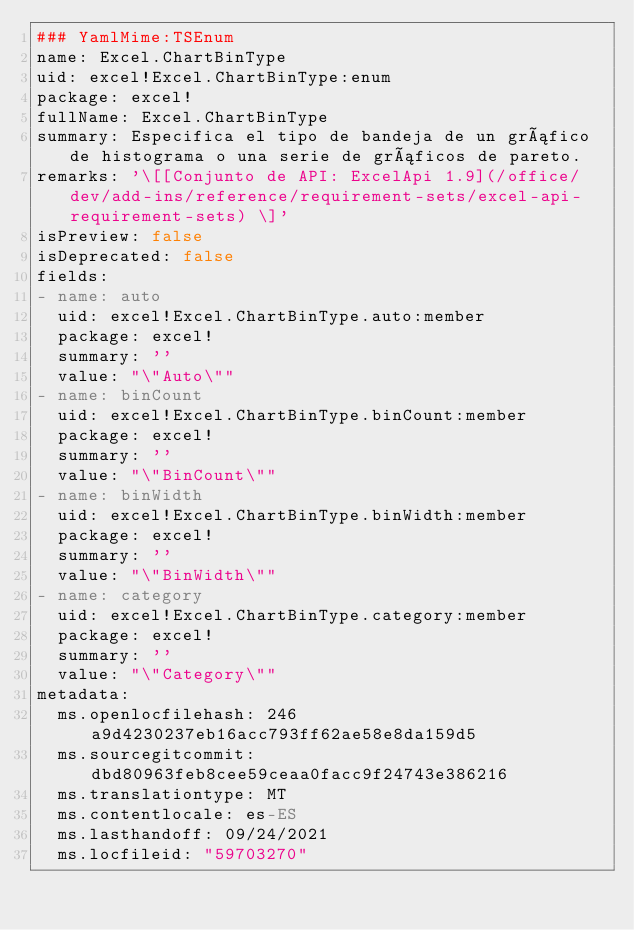Convert code to text. <code><loc_0><loc_0><loc_500><loc_500><_YAML_>### YamlMime:TSEnum
name: Excel.ChartBinType
uid: excel!Excel.ChartBinType:enum
package: excel!
fullName: Excel.ChartBinType
summary: Especifica el tipo de bandeja de un gráfico de histograma o una serie de gráficos de pareto.
remarks: '\[[Conjunto de API: ExcelApi 1.9](/office/dev/add-ins/reference/requirement-sets/excel-api-requirement-sets) \]'
isPreview: false
isDeprecated: false
fields:
- name: auto
  uid: excel!Excel.ChartBinType.auto:member
  package: excel!
  summary: ''
  value: "\"Auto\""
- name: binCount
  uid: excel!Excel.ChartBinType.binCount:member
  package: excel!
  summary: ''
  value: "\"BinCount\""
- name: binWidth
  uid: excel!Excel.ChartBinType.binWidth:member
  package: excel!
  summary: ''
  value: "\"BinWidth\""
- name: category
  uid: excel!Excel.ChartBinType.category:member
  package: excel!
  summary: ''
  value: "\"Category\""
metadata:
  ms.openlocfilehash: 246a9d4230237eb16acc793ff62ae58e8da159d5
  ms.sourcegitcommit: dbd80963feb8cee59ceaa0facc9f24743e386216
  ms.translationtype: MT
  ms.contentlocale: es-ES
  ms.lasthandoff: 09/24/2021
  ms.locfileid: "59703270"
</code> 